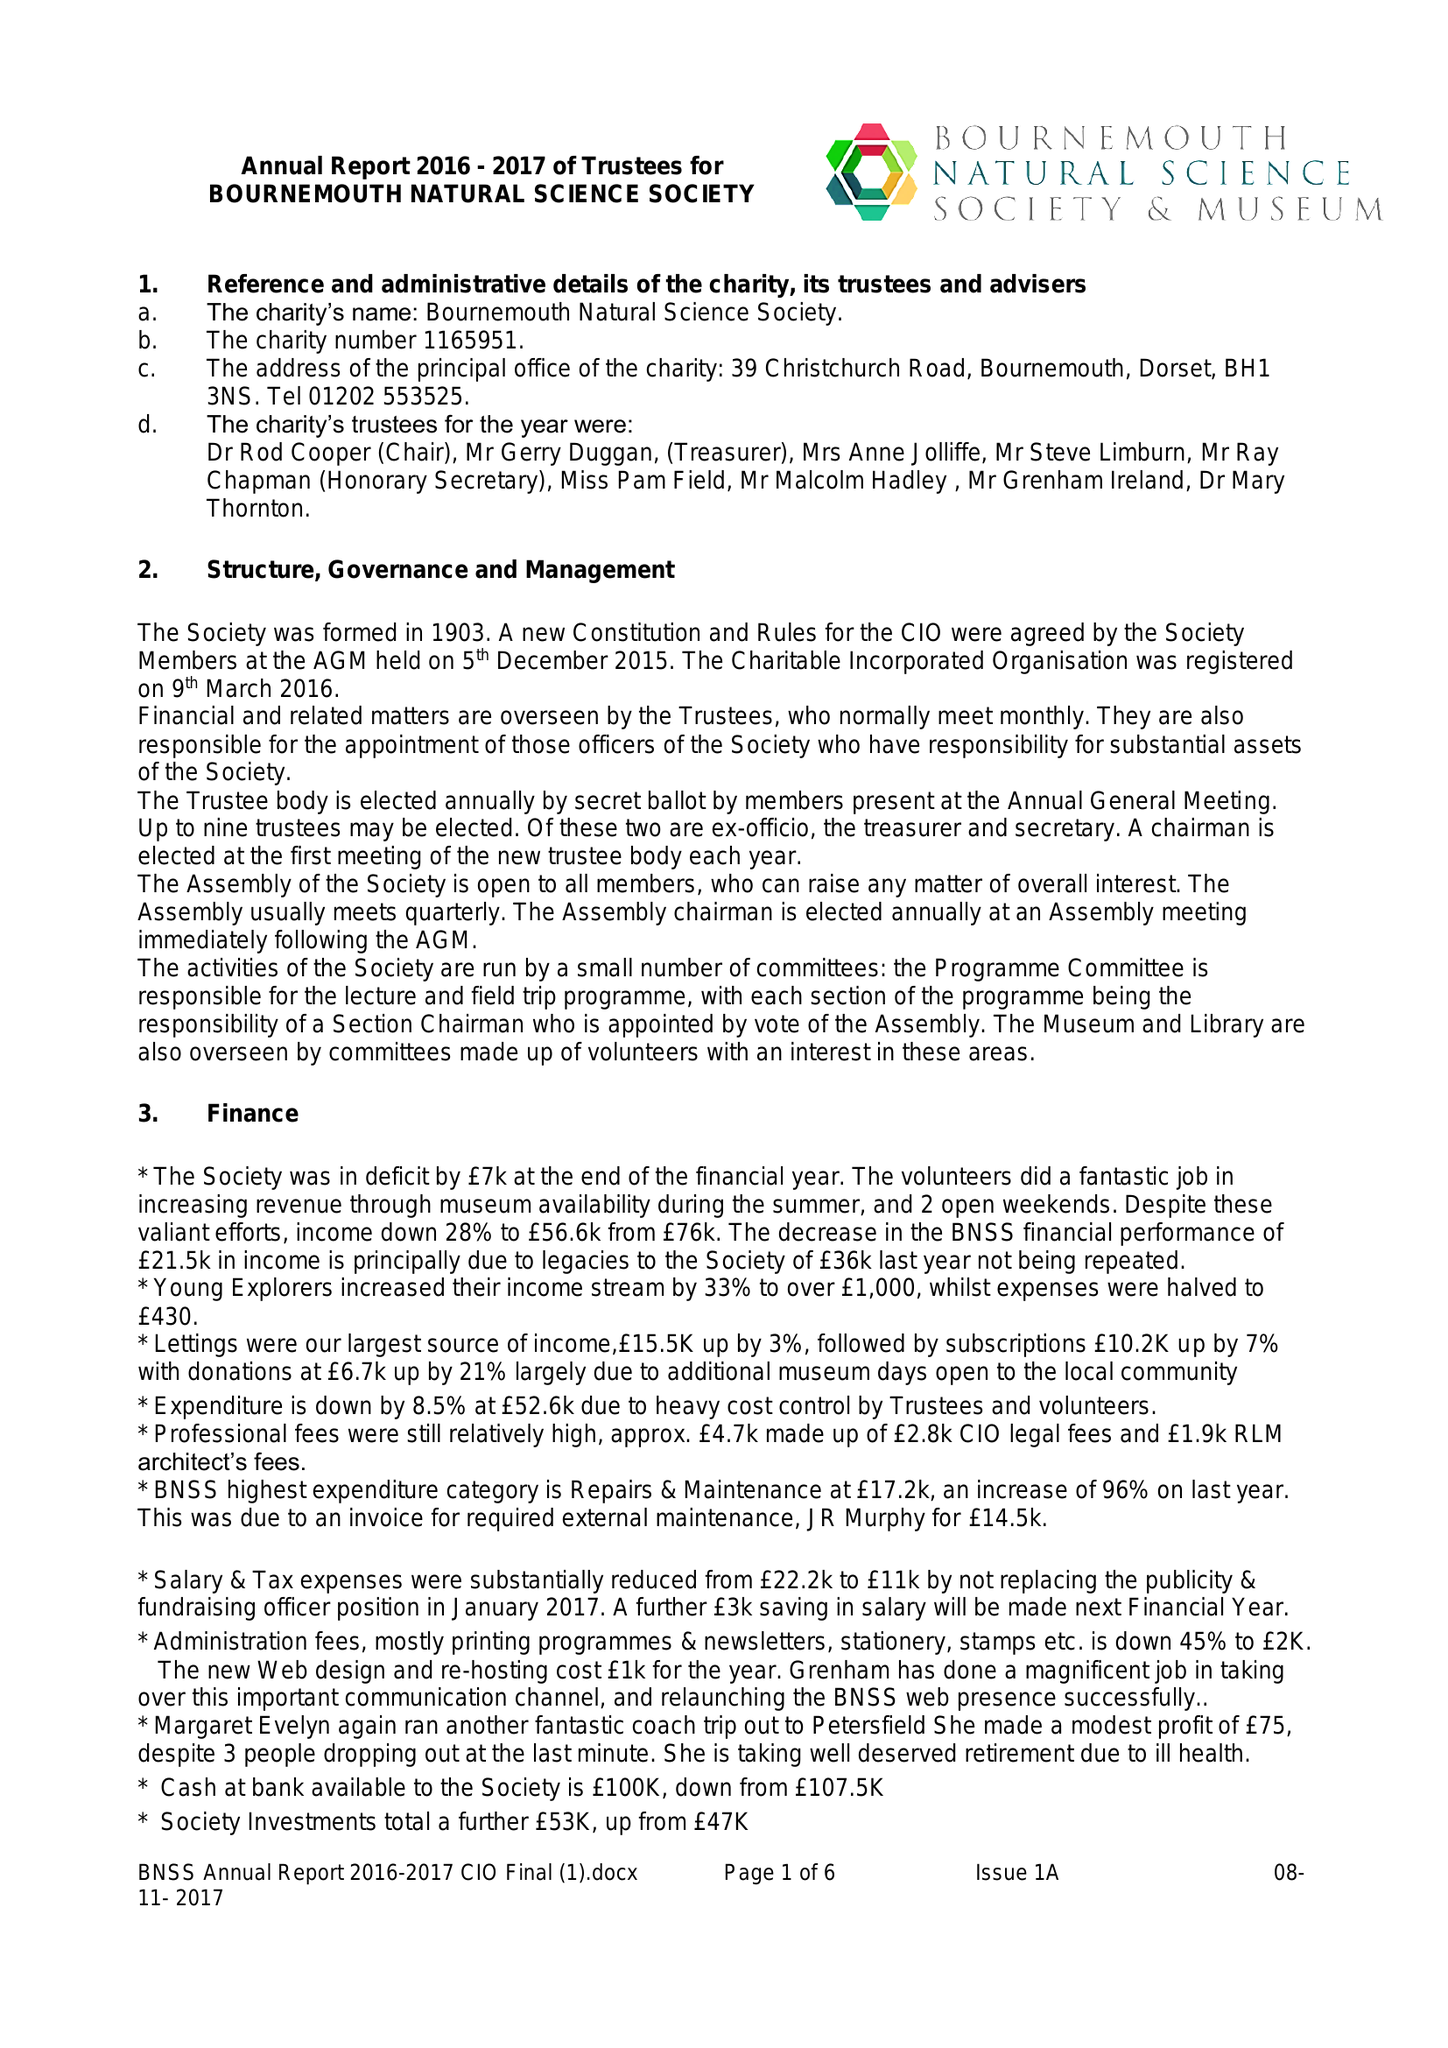What is the value for the charity_name?
Answer the question using a single word or phrase. Bournemouth Natural Science Society 